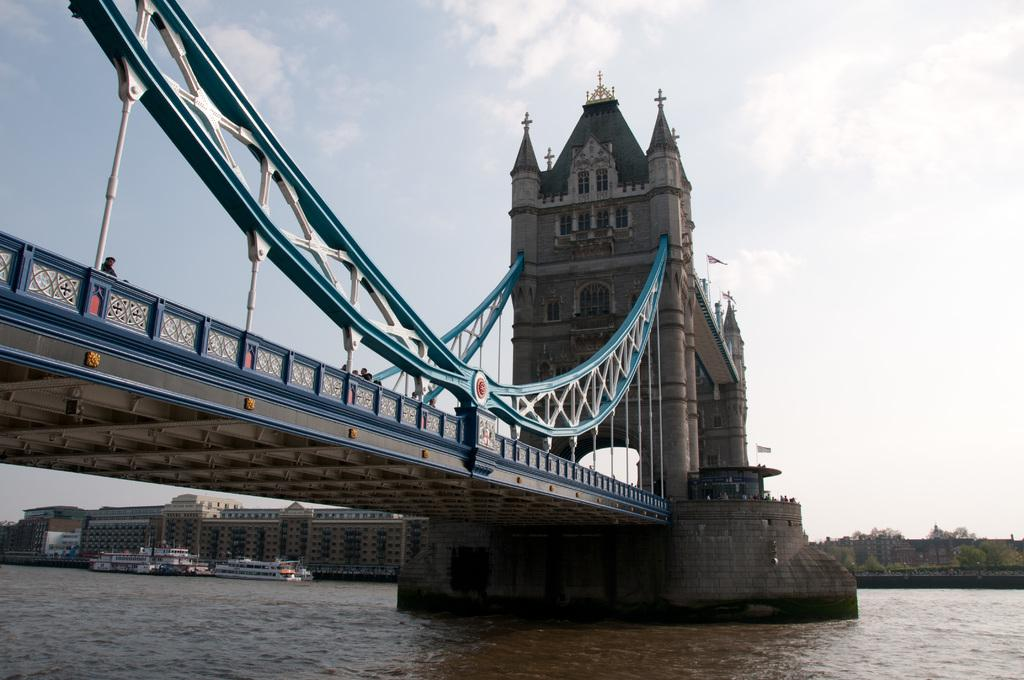What structure is located on the left side of the image? There is a bridge on the left side of the image. What is the bridge positioned above in the image? The bridge is positioned above a sea in the image. What can be seen in the background on the left side of the image? There are buildings in the background on the left side of the image. What type of vegetation is in the background on the right side of the image? There are trees in the background on the right side of the image. What is visible in the background of the image? The sky is visible in the background of the image, and clouds are present in the sky. What value does the bridge hold in the world of fiction in the image? The image does not depict a fictional world, and therefore the bridge does not hold any value in the world of fiction within the image. How does the grip of the trees on the right side of the image contribute to the overall composition? The image does not mention the grip of the trees, and trees do not have the ability to grip anything. 